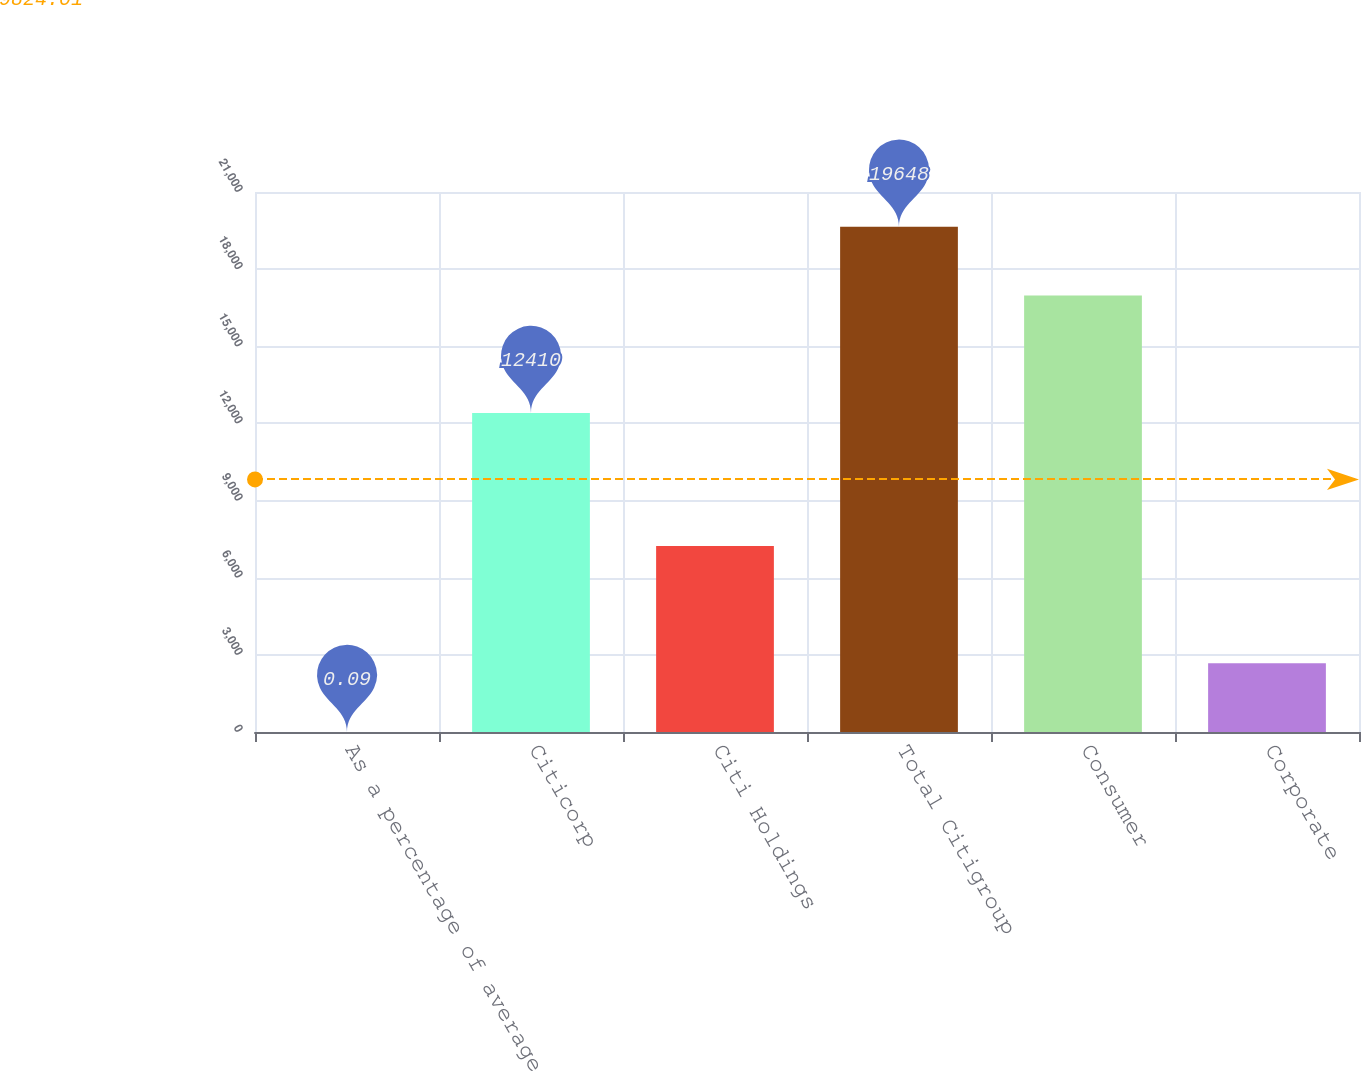Convert chart. <chart><loc_0><loc_0><loc_500><loc_500><bar_chart><fcel>As a percentage of average<fcel>Citicorp<fcel>Citi Holdings<fcel>Total Citigroup<fcel>Consumer<fcel>Corporate<nl><fcel>0.09<fcel>12410<fcel>7238<fcel>19648<fcel>16974<fcel>2674<nl></chart> 